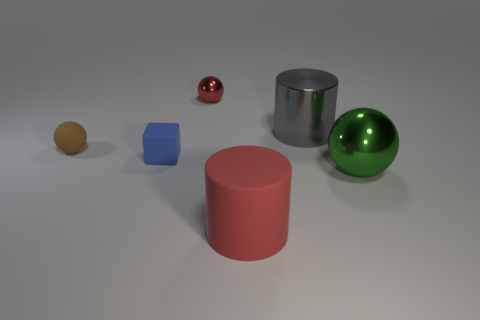If these objects were part of a physics study, which might be the focus? If this were a physics study, the focus might be on understanding the properties of different materials and shapes and how they interact with light - such as reflections, textures, and colors. Additionally, the study might explore concepts like density and mass by comparing objects of different sizes and materials. 